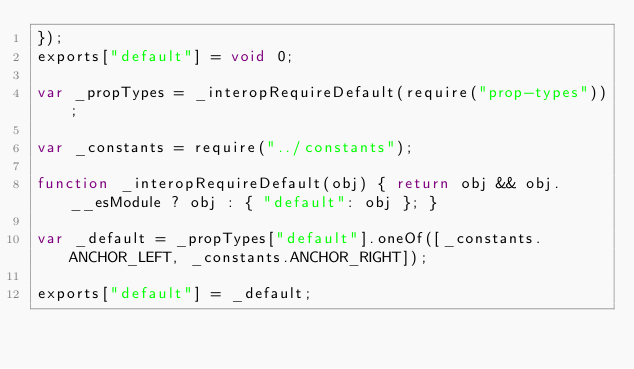<code> <loc_0><loc_0><loc_500><loc_500><_JavaScript_>});
exports["default"] = void 0;

var _propTypes = _interopRequireDefault(require("prop-types"));

var _constants = require("../constants");

function _interopRequireDefault(obj) { return obj && obj.__esModule ? obj : { "default": obj }; }

var _default = _propTypes["default"].oneOf([_constants.ANCHOR_LEFT, _constants.ANCHOR_RIGHT]);

exports["default"] = _default;</code> 